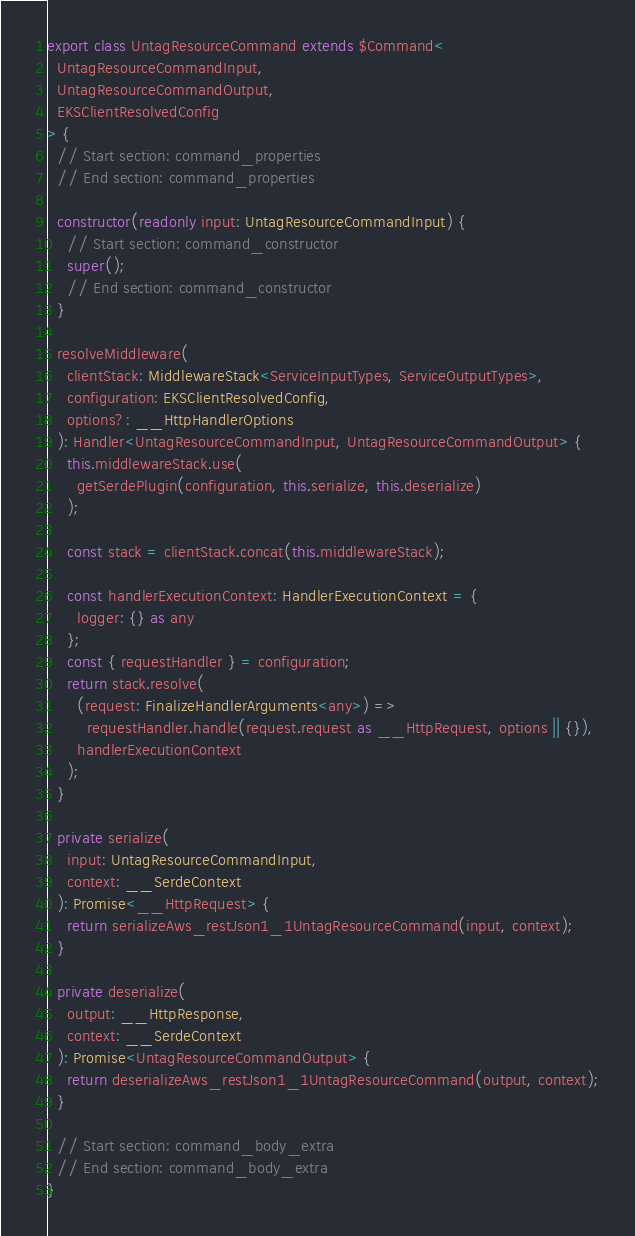Convert code to text. <code><loc_0><loc_0><loc_500><loc_500><_TypeScript_>
export class UntagResourceCommand extends $Command<
  UntagResourceCommandInput,
  UntagResourceCommandOutput,
  EKSClientResolvedConfig
> {
  // Start section: command_properties
  // End section: command_properties

  constructor(readonly input: UntagResourceCommandInput) {
    // Start section: command_constructor
    super();
    // End section: command_constructor
  }

  resolveMiddleware(
    clientStack: MiddlewareStack<ServiceInputTypes, ServiceOutputTypes>,
    configuration: EKSClientResolvedConfig,
    options?: __HttpHandlerOptions
  ): Handler<UntagResourceCommandInput, UntagResourceCommandOutput> {
    this.middlewareStack.use(
      getSerdePlugin(configuration, this.serialize, this.deserialize)
    );

    const stack = clientStack.concat(this.middlewareStack);

    const handlerExecutionContext: HandlerExecutionContext = {
      logger: {} as any
    };
    const { requestHandler } = configuration;
    return stack.resolve(
      (request: FinalizeHandlerArguments<any>) =>
        requestHandler.handle(request.request as __HttpRequest, options || {}),
      handlerExecutionContext
    );
  }

  private serialize(
    input: UntagResourceCommandInput,
    context: __SerdeContext
  ): Promise<__HttpRequest> {
    return serializeAws_restJson1_1UntagResourceCommand(input, context);
  }

  private deserialize(
    output: __HttpResponse,
    context: __SerdeContext
  ): Promise<UntagResourceCommandOutput> {
    return deserializeAws_restJson1_1UntagResourceCommand(output, context);
  }

  // Start section: command_body_extra
  // End section: command_body_extra
}
</code> 